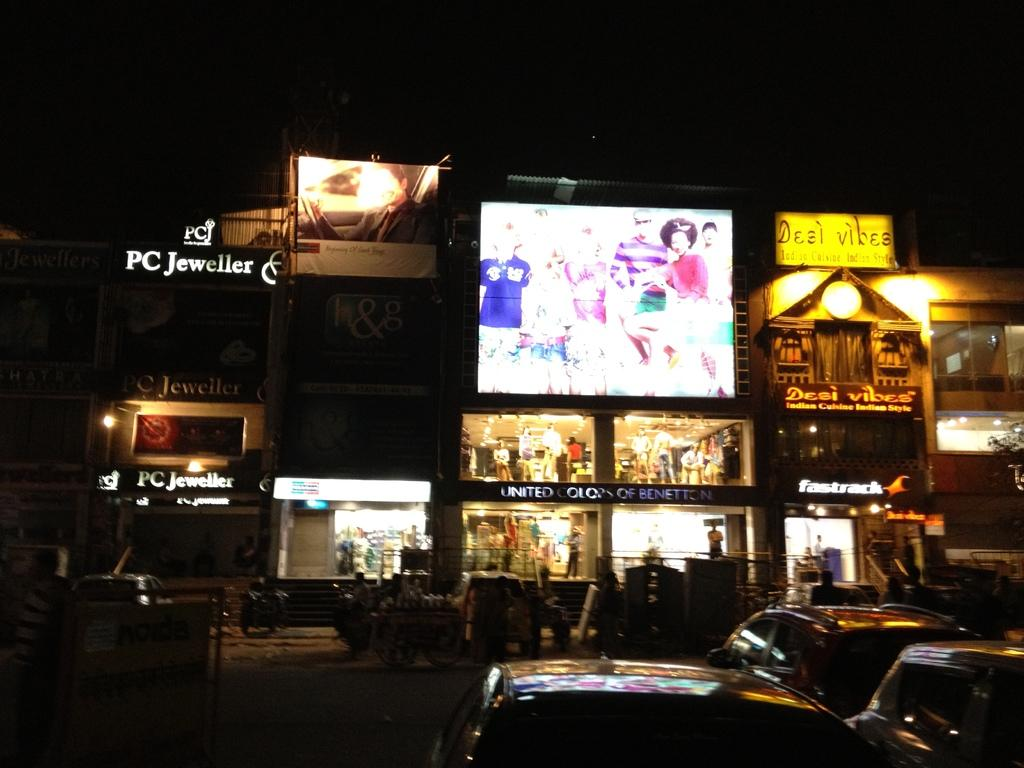Provide a one-sentence caption for the provided image. A small group of shops are bightly lit at night including Benneton, PC Jeweller and Desi Vibes. 